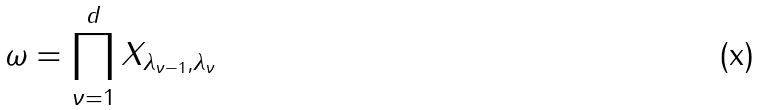Convert formula to latex. <formula><loc_0><loc_0><loc_500><loc_500>\omega = \prod _ { \nu = 1 } ^ { d } X _ { \lambda _ { \nu - 1 } , \lambda _ { \nu } }</formula> 